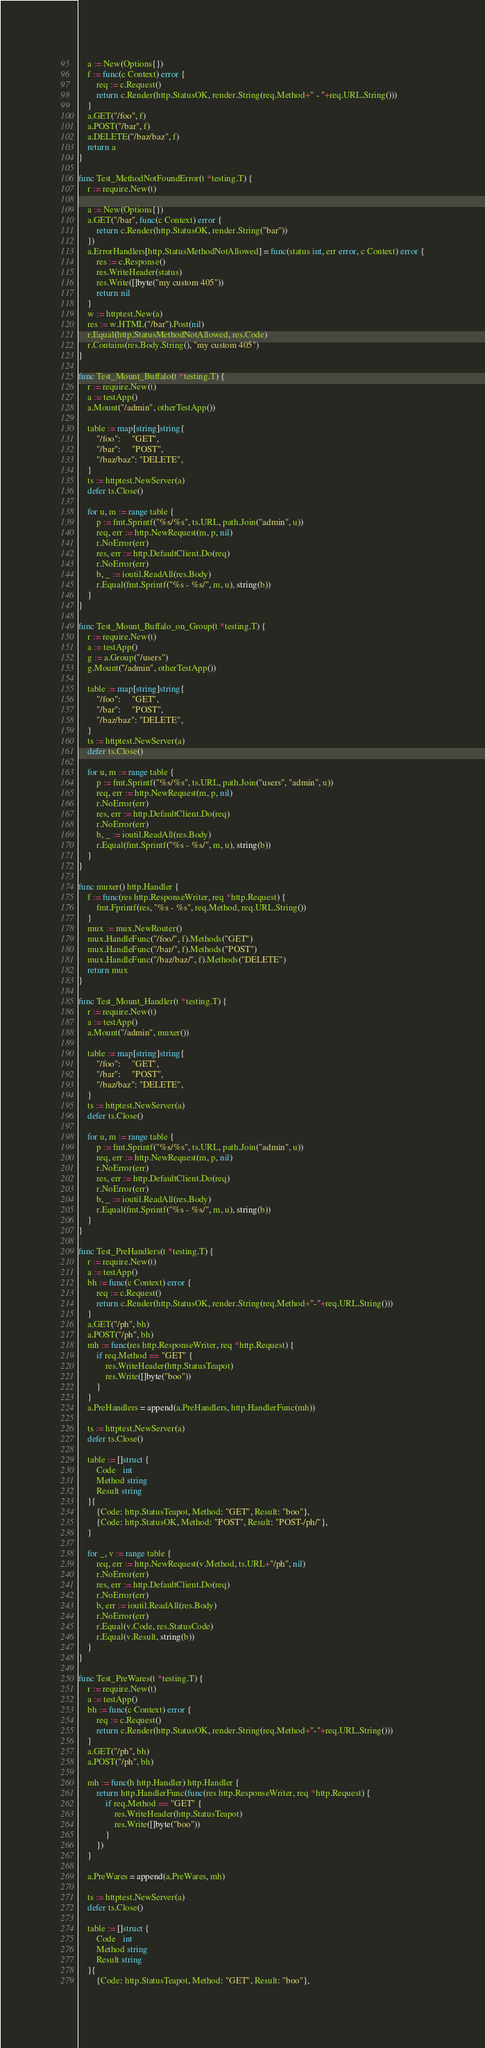<code> <loc_0><loc_0><loc_500><loc_500><_Go_>	a := New(Options{})
	f := func(c Context) error {
		req := c.Request()
		return c.Render(http.StatusOK, render.String(req.Method+" - "+req.URL.String()))
	}
	a.GET("/foo", f)
	a.POST("/bar", f)
	a.DELETE("/baz/baz", f)
	return a
}

func Test_MethodNotFoundError(t *testing.T) {
	r := require.New(t)

	a := New(Options{})
	a.GET("/bar", func(c Context) error {
		return c.Render(http.StatusOK, render.String("bar"))
	})
	a.ErrorHandlers[http.StatusMethodNotAllowed] = func(status int, err error, c Context) error {
		res := c.Response()
		res.WriteHeader(status)
		res.Write([]byte("my custom 405"))
		return nil
	}
	w := httptest.New(a)
	res := w.HTML("/bar").Post(nil)
	r.Equal(http.StatusMethodNotAllowed, res.Code)
	r.Contains(res.Body.String(), "my custom 405")
}

func Test_Mount_Buffalo(t *testing.T) {
	r := require.New(t)
	a := testApp()
	a.Mount("/admin", otherTestApp())

	table := map[string]string{
		"/foo":     "GET",
		"/bar":     "POST",
		"/baz/baz": "DELETE",
	}
	ts := httptest.NewServer(a)
	defer ts.Close()

	for u, m := range table {
		p := fmt.Sprintf("%s/%s", ts.URL, path.Join("admin", u))
		req, err := http.NewRequest(m, p, nil)
		r.NoError(err)
		res, err := http.DefaultClient.Do(req)
		r.NoError(err)
		b, _ := ioutil.ReadAll(res.Body)
		r.Equal(fmt.Sprintf("%s - %s/", m, u), string(b))
	}
}

func Test_Mount_Buffalo_on_Group(t *testing.T) {
	r := require.New(t)
	a := testApp()
	g := a.Group("/users")
	g.Mount("/admin", otherTestApp())

	table := map[string]string{
		"/foo":     "GET",
		"/bar":     "POST",
		"/baz/baz": "DELETE",
	}
	ts := httptest.NewServer(a)
	defer ts.Close()

	for u, m := range table {
		p := fmt.Sprintf("%s/%s", ts.URL, path.Join("users", "admin", u))
		req, err := http.NewRequest(m, p, nil)
		r.NoError(err)
		res, err := http.DefaultClient.Do(req)
		r.NoError(err)
		b, _ := ioutil.ReadAll(res.Body)
		r.Equal(fmt.Sprintf("%s - %s/", m, u), string(b))
	}
}

func muxer() http.Handler {
	f := func(res http.ResponseWriter, req *http.Request) {
		fmt.Fprintf(res, "%s - %s", req.Method, req.URL.String())
	}
	mux := mux.NewRouter()
	mux.HandleFunc("/foo/", f).Methods("GET")
	mux.HandleFunc("/bar/", f).Methods("POST")
	mux.HandleFunc("/baz/baz/", f).Methods("DELETE")
	return mux
}

func Test_Mount_Handler(t *testing.T) {
	r := require.New(t)
	a := testApp()
	a.Mount("/admin", muxer())

	table := map[string]string{
		"/foo":     "GET",
		"/bar":     "POST",
		"/baz/baz": "DELETE",
	}
	ts := httptest.NewServer(a)
	defer ts.Close()

	for u, m := range table {
		p := fmt.Sprintf("%s/%s", ts.URL, path.Join("admin", u))
		req, err := http.NewRequest(m, p, nil)
		r.NoError(err)
		res, err := http.DefaultClient.Do(req)
		r.NoError(err)
		b, _ := ioutil.ReadAll(res.Body)
		r.Equal(fmt.Sprintf("%s - %s/", m, u), string(b))
	}
}

func Test_PreHandlers(t *testing.T) {
	r := require.New(t)
	a := testApp()
	bh := func(c Context) error {
		req := c.Request()
		return c.Render(http.StatusOK, render.String(req.Method+"-"+req.URL.String()))
	}
	a.GET("/ph", bh)
	a.POST("/ph", bh)
	mh := func(res http.ResponseWriter, req *http.Request) {
		if req.Method == "GET" {
			res.WriteHeader(http.StatusTeapot)
			res.Write([]byte("boo"))
		}
	}
	a.PreHandlers = append(a.PreHandlers, http.HandlerFunc(mh))

	ts := httptest.NewServer(a)
	defer ts.Close()

	table := []struct {
		Code   int
		Method string
		Result string
	}{
		{Code: http.StatusTeapot, Method: "GET", Result: "boo"},
		{Code: http.StatusOK, Method: "POST", Result: "POST-/ph/"},
	}

	for _, v := range table {
		req, err := http.NewRequest(v.Method, ts.URL+"/ph", nil)
		r.NoError(err)
		res, err := http.DefaultClient.Do(req)
		r.NoError(err)
		b, err := ioutil.ReadAll(res.Body)
		r.NoError(err)
		r.Equal(v.Code, res.StatusCode)
		r.Equal(v.Result, string(b))
	}
}

func Test_PreWares(t *testing.T) {
	r := require.New(t)
	a := testApp()
	bh := func(c Context) error {
		req := c.Request()
		return c.Render(http.StatusOK, render.String(req.Method+"-"+req.URL.String()))
	}
	a.GET("/ph", bh)
	a.POST("/ph", bh)

	mh := func(h http.Handler) http.Handler {
		return http.HandlerFunc(func(res http.ResponseWriter, req *http.Request) {
			if req.Method == "GET" {
				res.WriteHeader(http.StatusTeapot)
				res.Write([]byte("boo"))
			}
		})
	}

	a.PreWares = append(a.PreWares, mh)

	ts := httptest.NewServer(a)
	defer ts.Close()

	table := []struct {
		Code   int
		Method string
		Result string
	}{
		{Code: http.StatusTeapot, Method: "GET", Result: "boo"},</code> 